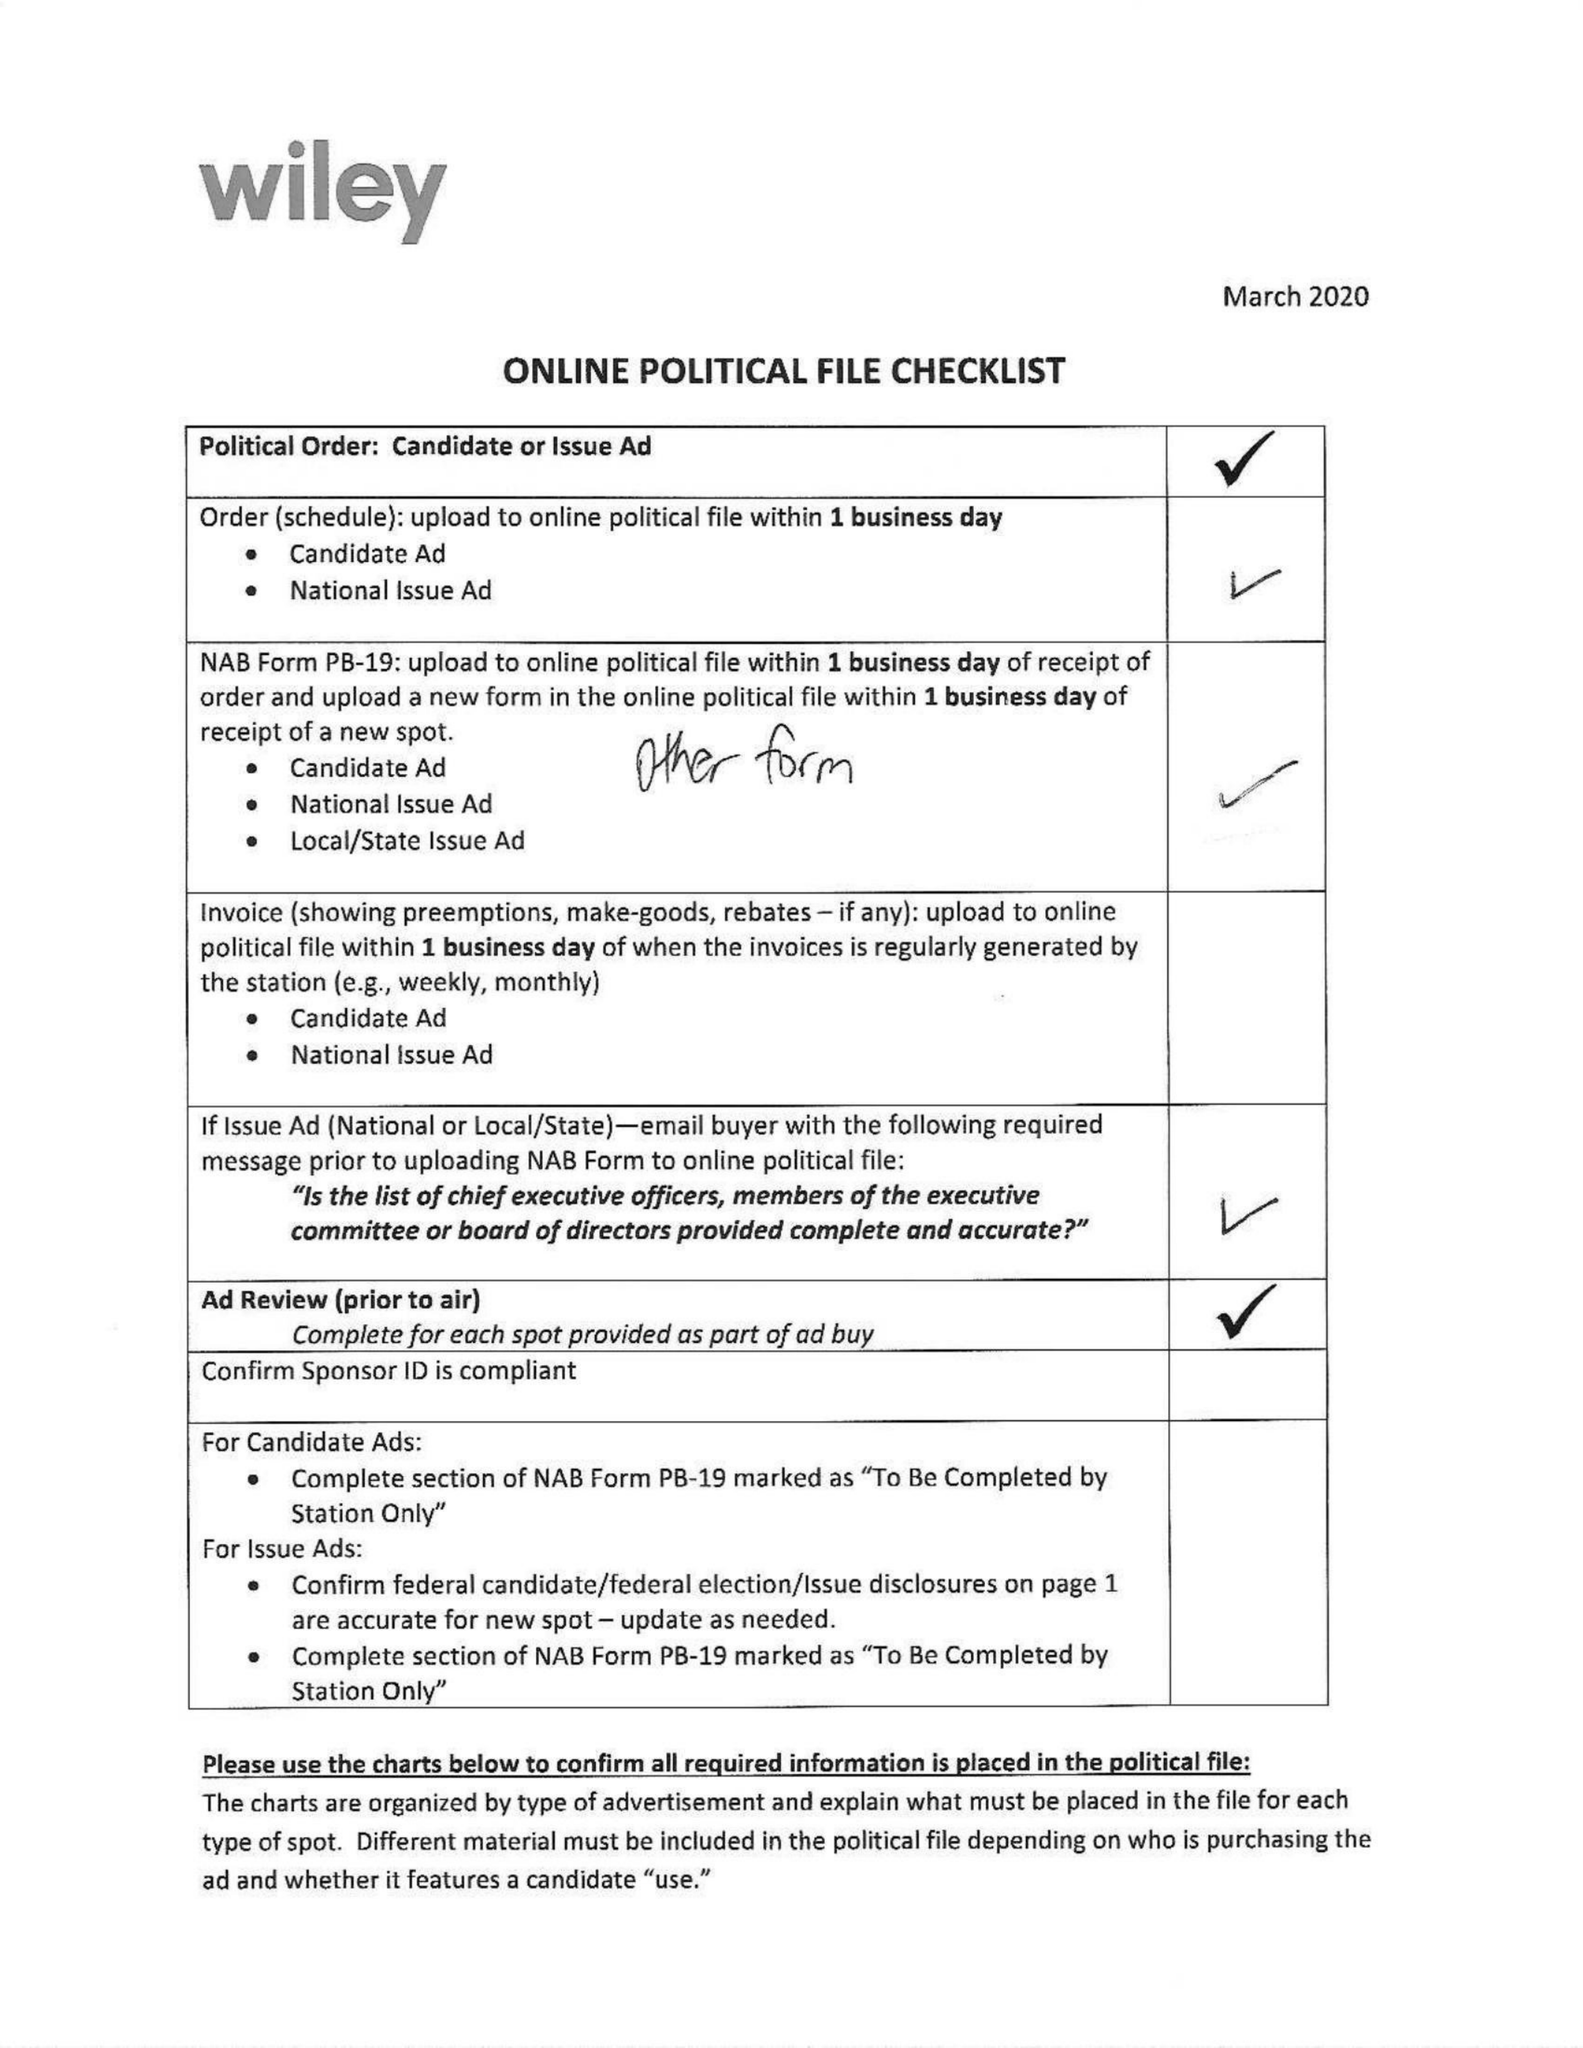What is the value for the gross_amount?
Answer the question using a single word or phrase. 68883.00 